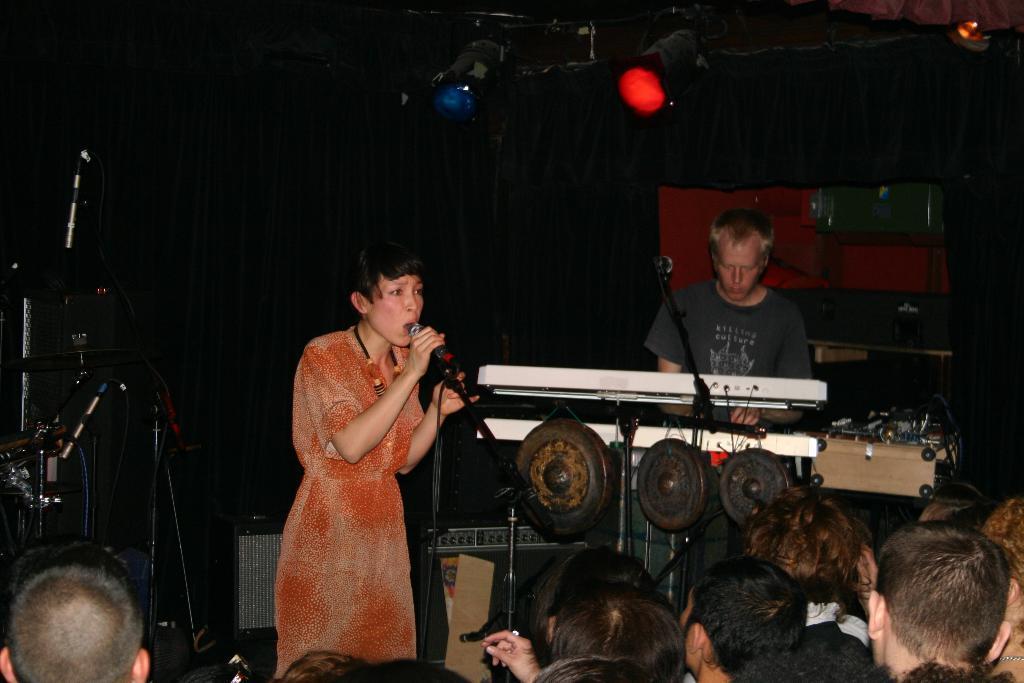How would you summarize this image in a sentence or two? In the image there are a group of people in the foreground and in front of the people there is a woman singing a song, around the woman there are music equipment and behind her there is a man and he is playing a music instrument and in the background there are lights and a curtain. 